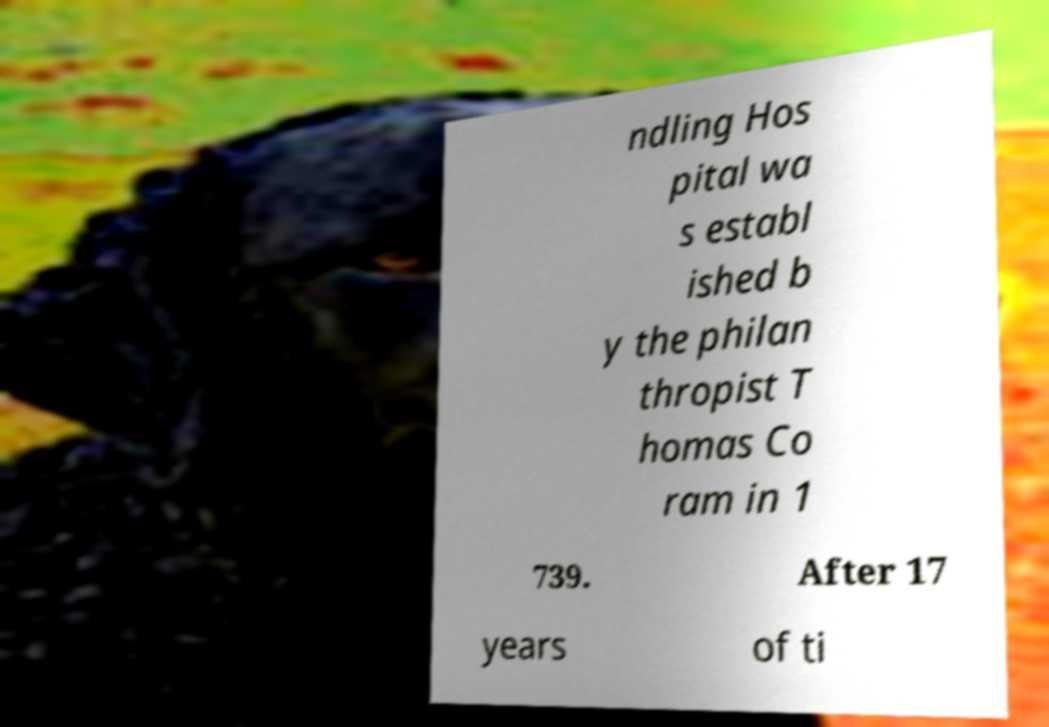I need the written content from this picture converted into text. Can you do that? ndling Hos pital wa s establ ished b y the philan thropist T homas Co ram in 1 739. After 17 years of ti 